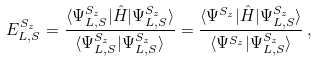<formula> <loc_0><loc_0><loc_500><loc_500>E _ { L , S } ^ { S _ { z } } = \frac { \langle \Psi _ { L , S } ^ { S _ { z } } | \hat { H } | \Psi _ { L , S } ^ { S _ { z } } \rangle } { \langle \Psi _ { L , S } ^ { S _ { z } } | \Psi _ { L , S } ^ { S _ { z } } \rangle } = \frac { \langle \Psi ^ { S _ { z } } | \hat { H } | \Psi _ { L , S } ^ { S _ { z } } \rangle } { \langle \Psi ^ { S _ { z } } | \Psi _ { L , S } ^ { S _ { z } } \rangle } \, ,</formula> 